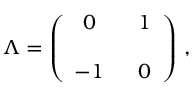Convert formula to latex. <formula><loc_0><loc_0><loc_500><loc_500>\Lambda = \left ( \begin{array} { c c } { 0 } & { \, 1 } \\ { - 1 } & { \, 0 } \end{array} \right ) \, ,</formula> 